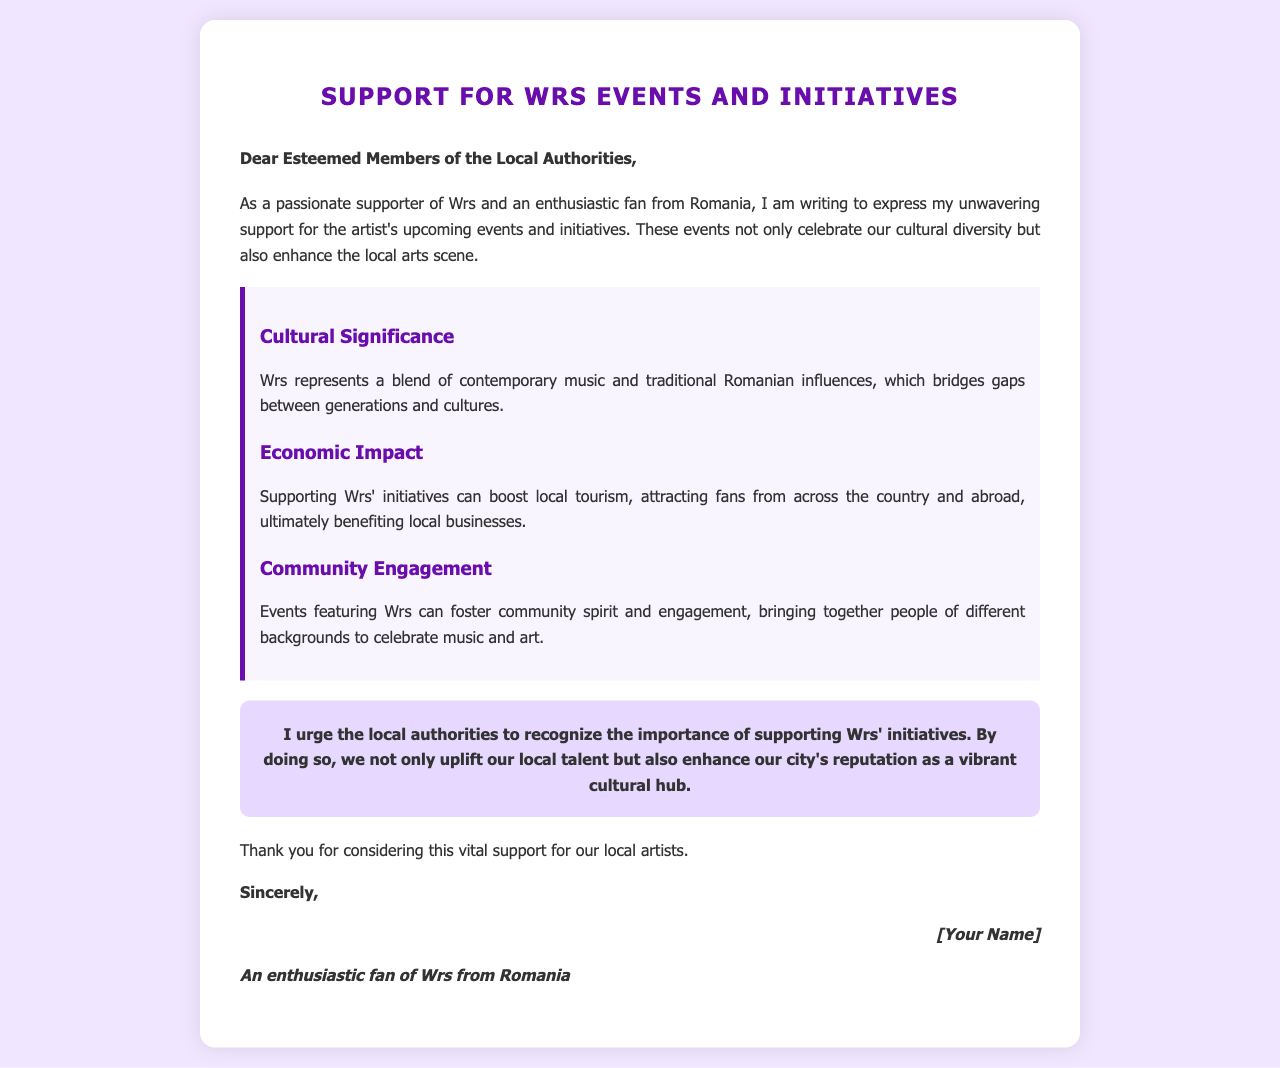What is the main purpose of the letter? The letter expresses support for Wrs' upcoming events and initiatives, highlighting their significance.
Answer: support for Wrs' events Who is the author of the letter? The author signs off as "An enthusiastic fan of Wrs from Romania."
Answer: [Your Name] What cultural aspect does Wrs represent according to the letter? The letter describes Wrs as representing a blend of contemporary music and traditional Romanian influences.
Answer: cultural diversity What are two benefits of supporting Wrs' initiatives mentioned in the letter? The letter discusses both economic impact and community engagement as benefits of supporting Wrs' initiatives.
Answer: economic impact and community engagement What is urged from the local authorities in the letter? The author urges the local authorities to recognize the importance of supporting Wrs' initiatives.
Answer: recognition of support How many importance items are listed in the letter? There are three importance items listed under the importance section of the letter.
Answer: three What is the background color of the letter's body? The background color of the letter's body is a light purple tone.
Answer: light purple What is the closing salutation of the letter? The closing salutation of the letter is "Sincerely," followed by the author's name and description.
Answer: Sincerely What kind of tone does the letter convey about local talent? The letter conveys an uplifting tone regarding local talent and its cultural importance.
Answer: uplifting tone 